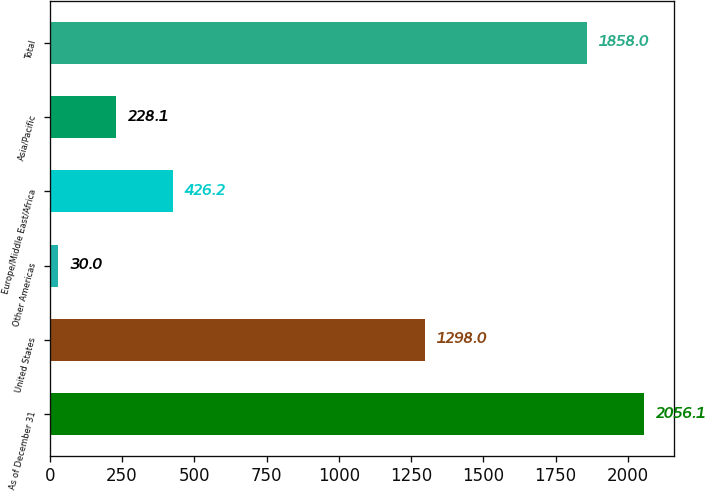<chart> <loc_0><loc_0><loc_500><loc_500><bar_chart><fcel>As of December 31<fcel>United States<fcel>Other Americas<fcel>Europe/Middle East/Africa<fcel>Asia/Pacific<fcel>Total<nl><fcel>2056.1<fcel>1298<fcel>30<fcel>426.2<fcel>228.1<fcel>1858<nl></chart> 